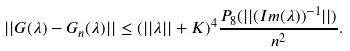<formula> <loc_0><loc_0><loc_500><loc_500>| | G ( \lambda ) - G _ { n } ( \lambda ) | | \leq ( | | \lambda | | + K ) ^ { 4 } \frac { P _ { 8 } ( | | ( I m ( \lambda ) ) ^ { - 1 } | | ) } { n ^ { 2 } } .</formula> 